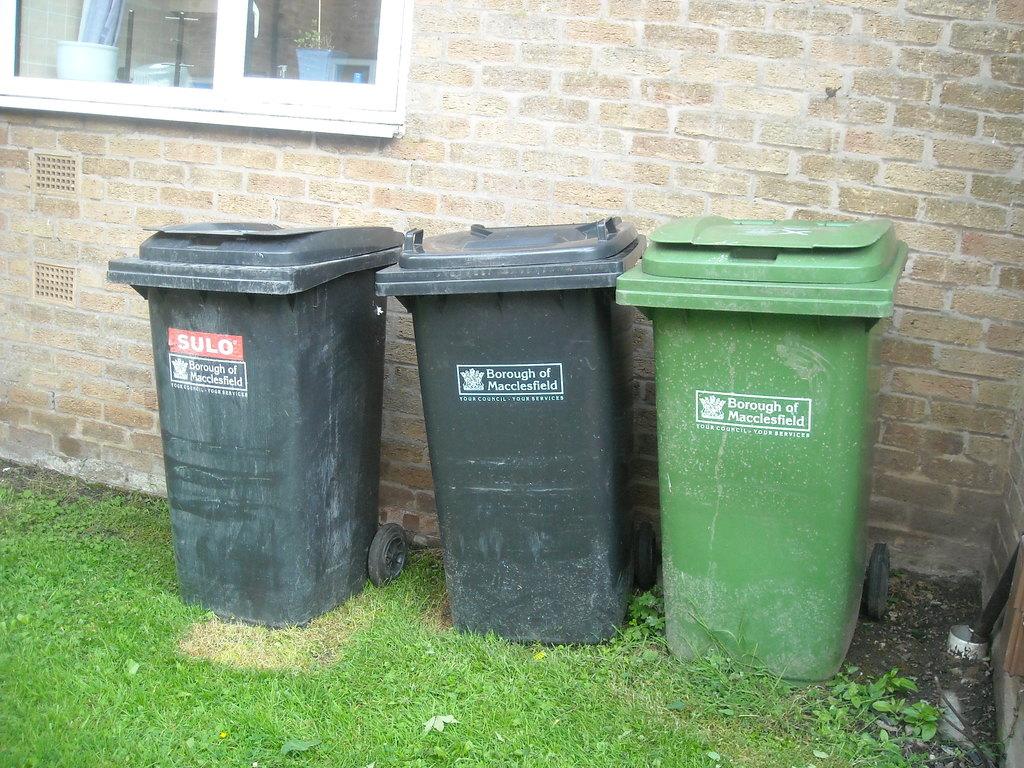What does it say in white text with red background on the trash can to the far left?
Your answer should be very brief. Sulo. What city provides these trash cans?
Your response must be concise. Macclesfield. 